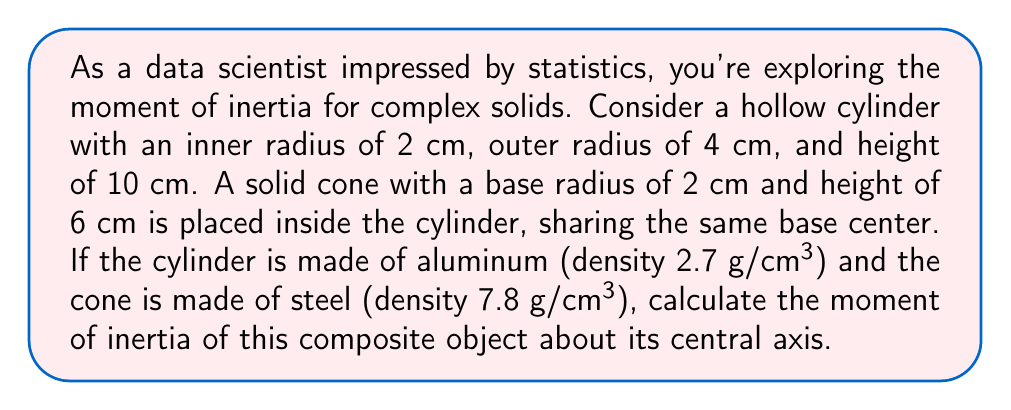Help me with this question. Let's approach this step-by-step:

1) First, we need to calculate the moments of inertia for each component separately.

2) For a hollow cylinder about its central axis:
   $$I_{cylinder} = \frac{1}{2}m(r_1^2 + r_2^2)$$
   where $m$ is the mass, $r_1$ is the inner radius, and $r_2$ is the outer radius.

3) For a solid cone about its central axis:
   $$I_{cone} = \frac{3}{10}mr^2$$
   where $m$ is the mass and $r$ is the base radius.

4) Calculate the mass of the cylinder:
   $$V_{cylinder} = \pi(r_2^2 - r_1^2)h = \pi(4^2 - 2^2)10 = 90\pi \text{ cm}^3$$
   $$m_{cylinder} = 2.7 \text{ g/cm}^3 \times 90\pi \text{ cm}^3 = 243\pi \text{ g}$$

5) Calculate the mass of the cone:
   $$V_{cone} = \frac{1}{3}\pi r^2 h = \frac{1}{3}\pi(2^2)(6) = 8\pi \text{ cm}^3$$
   $$m_{cone} = 7.8 \text{ g/cm}^3 \times 8\pi \text{ cm}^3 = 62.4\pi \text{ g}$$

6) Calculate the moment of inertia for the cylinder:
   $$I_{cylinder} = \frac{1}{2}(243\pi)(2^2 + 4^2) = 1,215\pi \text{ g⋅cm}^2$$

7) Calculate the moment of inertia for the cone:
   $$I_{cone} = \frac{3}{10}(62.4\pi)(2^2) = 74.88\pi \text{ g⋅cm}^2$$

8) The total moment of inertia is the sum of these two:
   $$I_{total} = I_{cylinder} + I_{cone} = 1,215\pi + 74.88\pi = 1,289.88\pi \text{ g⋅cm}^2$$
Answer: $1,289.88\pi \text{ g⋅cm}^2$ 